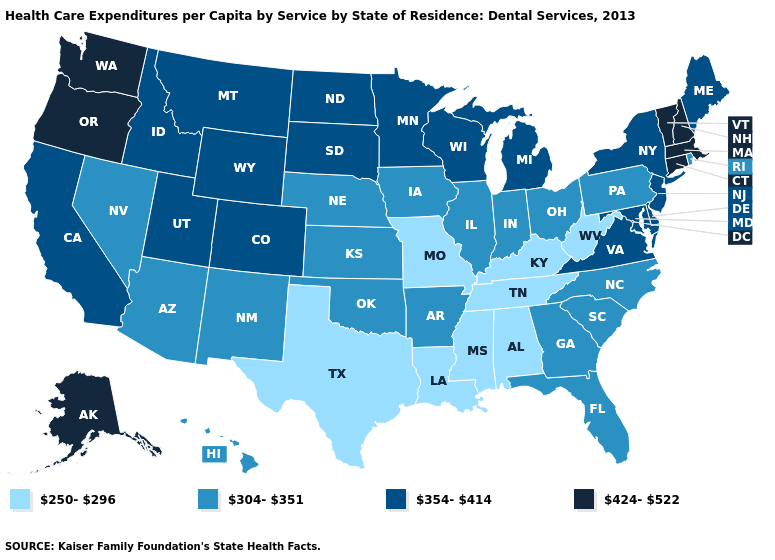Does Ohio have a higher value than Missouri?
Quick response, please. Yes. What is the value of Alaska?
Be succinct. 424-522. What is the lowest value in the Northeast?
Concise answer only. 304-351. How many symbols are there in the legend?
Quick response, please. 4. How many symbols are there in the legend?
Write a very short answer. 4. Does Nevada have the lowest value in the West?
Quick response, please. Yes. Name the states that have a value in the range 354-414?
Short answer required. California, Colorado, Delaware, Idaho, Maine, Maryland, Michigan, Minnesota, Montana, New Jersey, New York, North Dakota, South Dakota, Utah, Virginia, Wisconsin, Wyoming. What is the value of Louisiana?
Concise answer only. 250-296. Does the first symbol in the legend represent the smallest category?
Short answer required. Yes. What is the highest value in the USA?
Be succinct. 424-522. Name the states that have a value in the range 304-351?
Concise answer only. Arizona, Arkansas, Florida, Georgia, Hawaii, Illinois, Indiana, Iowa, Kansas, Nebraska, Nevada, New Mexico, North Carolina, Ohio, Oklahoma, Pennsylvania, Rhode Island, South Carolina. What is the highest value in the South ?
Give a very brief answer. 354-414. Among the states that border Wyoming , which have the highest value?
Short answer required. Colorado, Idaho, Montana, South Dakota, Utah. Name the states that have a value in the range 424-522?
Be succinct. Alaska, Connecticut, Massachusetts, New Hampshire, Oregon, Vermont, Washington. Which states have the lowest value in the MidWest?
Be succinct. Missouri. 